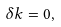<formula> <loc_0><loc_0><loc_500><loc_500>\delta k = 0 ,</formula> 